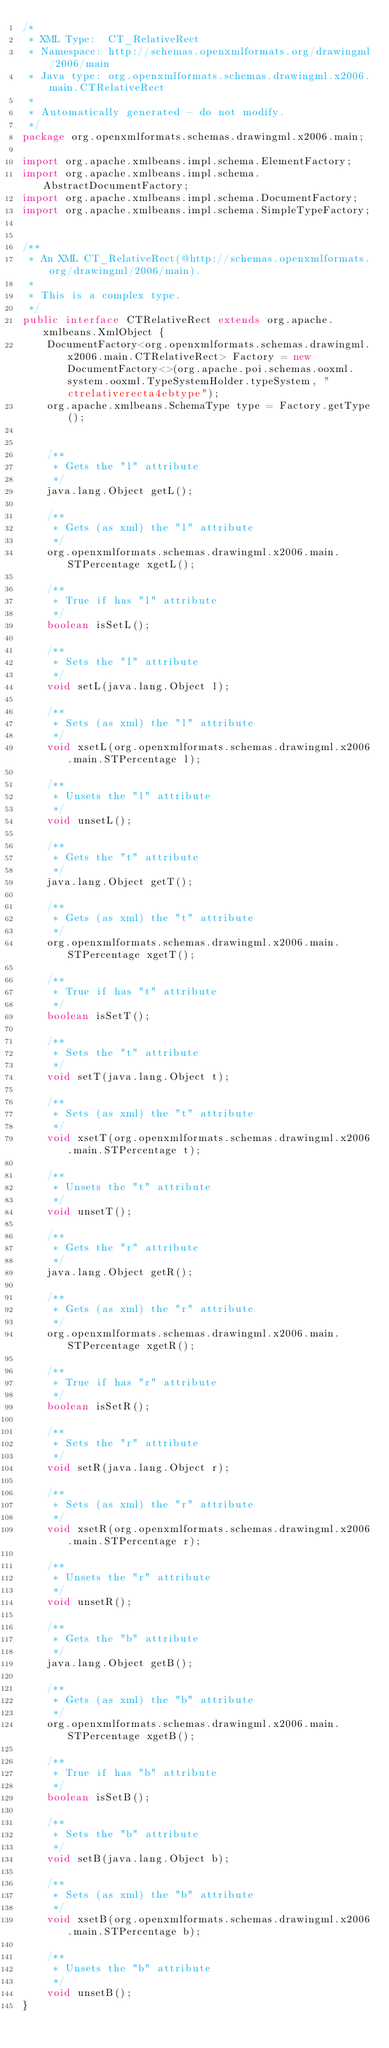<code> <loc_0><loc_0><loc_500><loc_500><_Java_>/*
 * XML Type:  CT_RelativeRect
 * Namespace: http://schemas.openxmlformats.org/drawingml/2006/main
 * Java type: org.openxmlformats.schemas.drawingml.x2006.main.CTRelativeRect
 *
 * Automatically generated - do not modify.
 */
package org.openxmlformats.schemas.drawingml.x2006.main;

import org.apache.xmlbeans.impl.schema.ElementFactory;
import org.apache.xmlbeans.impl.schema.AbstractDocumentFactory;
import org.apache.xmlbeans.impl.schema.DocumentFactory;
import org.apache.xmlbeans.impl.schema.SimpleTypeFactory;


/**
 * An XML CT_RelativeRect(@http://schemas.openxmlformats.org/drawingml/2006/main).
 *
 * This is a complex type.
 */
public interface CTRelativeRect extends org.apache.xmlbeans.XmlObject {
    DocumentFactory<org.openxmlformats.schemas.drawingml.x2006.main.CTRelativeRect> Factory = new DocumentFactory<>(org.apache.poi.schemas.ooxml.system.ooxml.TypeSystemHolder.typeSystem, "ctrelativerecta4ebtype");
    org.apache.xmlbeans.SchemaType type = Factory.getType();


    /**
     * Gets the "l" attribute
     */
    java.lang.Object getL();

    /**
     * Gets (as xml) the "l" attribute
     */
    org.openxmlformats.schemas.drawingml.x2006.main.STPercentage xgetL();

    /**
     * True if has "l" attribute
     */
    boolean isSetL();

    /**
     * Sets the "l" attribute
     */
    void setL(java.lang.Object l);

    /**
     * Sets (as xml) the "l" attribute
     */
    void xsetL(org.openxmlformats.schemas.drawingml.x2006.main.STPercentage l);

    /**
     * Unsets the "l" attribute
     */
    void unsetL();

    /**
     * Gets the "t" attribute
     */
    java.lang.Object getT();

    /**
     * Gets (as xml) the "t" attribute
     */
    org.openxmlformats.schemas.drawingml.x2006.main.STPercentage xgetT();

    /**
     * True if has "t" attribute
     */
    boolean isSetT();

    /**
     * Sets the "t" attribute
     */
    void setT(java.lang.Object t);

    /**
     * Sets (as xml) the "t" attribute
     */
    void xsetT(org.openxmlformats.schemas.drawingml.x2006.main.STPercentage t);

    /**
     * Unsets the "t" attribute
     */
    void unsetT();

    /**
     * Gets the "r" attribute
     */
    java.lang.Object getR();

    /**
     * Gets (as xml) the "r" attribute
     */
    org.openxmlformats.schemas.drawingml.x2006.main.STPercentage xgetR();

    /**
     * True if has "r" attribute
     */
    boolean isSetR();

    /**
     * Sets the "r" attribute
     */
    void setR(java.lang.Object r);

    /**
     * Sets (as xml) the "r" attribute
     */
    void xsetR(org.openxmlformats.schemas.drawingml.x2006.main.STPercentage r);

    /**
     * Unsets the "r" attribute
     */
    void unsetR();

    /**
     * Gets the "b" attribute
     */
    java.lang.Object getB();

    /**
     * Gets (as xml) the "b" attribute
     */
    org.openxmlformats.schemas.drawingml.x2006.main.STPercentage xgetB();

    /**
     * True if has "b" attribute
     */
    boolean isSetB();

    /**
     * Sets the "b" attribute
     */
    void setB(java.lang.Object b);

    /**
     * Sets (as xml) the "b" attribute
     */
    void xsetB(org.openxmlformats.schemas.drawingml.x2006.main.STPercentage b);

    /**
     * Unsets the "b" attribute
     */
    void unsetB();
}
</code> 